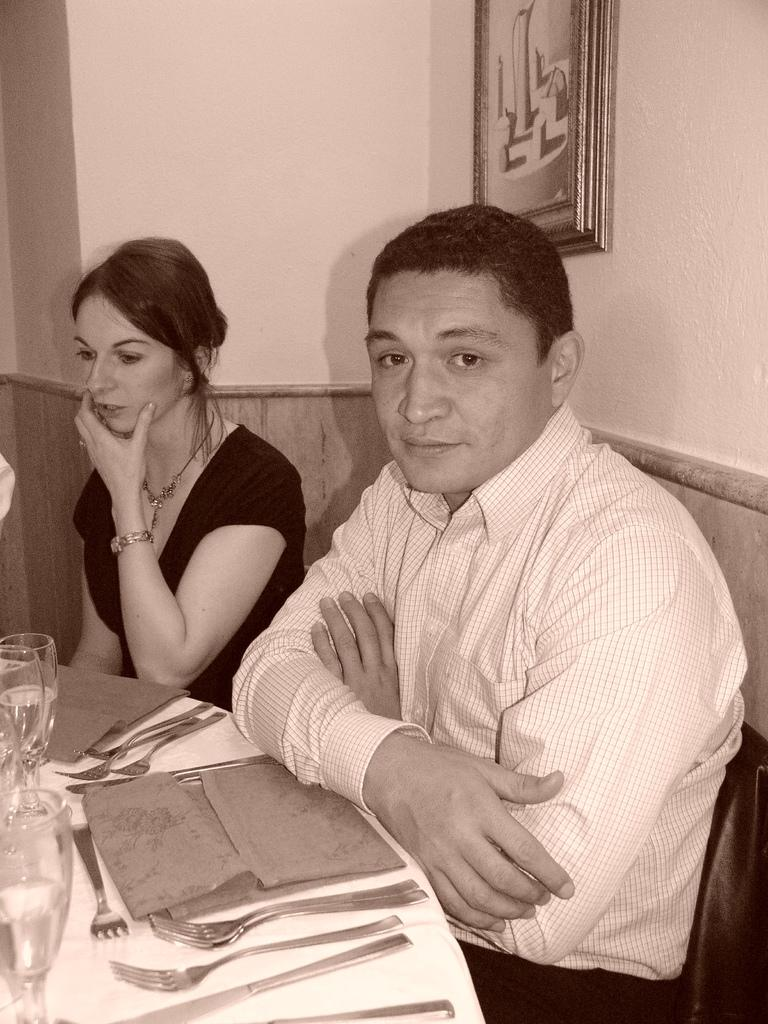How many people are in the image? There are two people in the image, a man and a woman. What are the man and woman doing in the image? The man and woman are sitting around a table. What items can be seen on the table in the image? There is a napkin, spoons, and a glass with water on the table. What type of mint is being used to flavor the song in the image? There is no mention of mint or a song in the image; it features a man and a woman sitting around a table with a napkin, spoons, and a glass with water. 